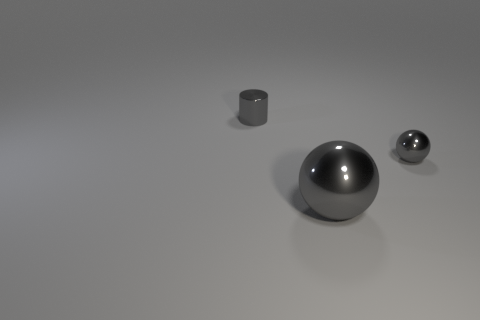What number of other objects are there of the same size as the cylinder?
Keep it short and to the point. 1. Is the size of the gray metallic cylinder the same as the shiny object that is in front of the small gray metal sphere?
Offer a terse response. No. Are there any tiny things of the same color as the big object?
Provide a short and direct response. Yes. What number of big objects are gray shiny balls or gray cylinders?
Offer a very short reply. 1. How many tiny green objects are there?
Ensure brevity in your answer.  0. What material is the small gray thing that is right of the gray metal cylinder?
Your answer should be compact. Metal. There is a cylinder; are there any big gray metal spheres right of it?
Offer a very short reply. Yes. What number of small gray objects are made of the same material as the cylinder?
Keep it short and to the point. 1. How big is the ball that is in front of the small gray shiny object in front of the tiny metal cylinder?
Your answer should be compact. Large. What color is the metal thing that is both on the left side of the tiny gray sphere and to the right of the metallic cylinder?
Your response must be concise. Gray. 